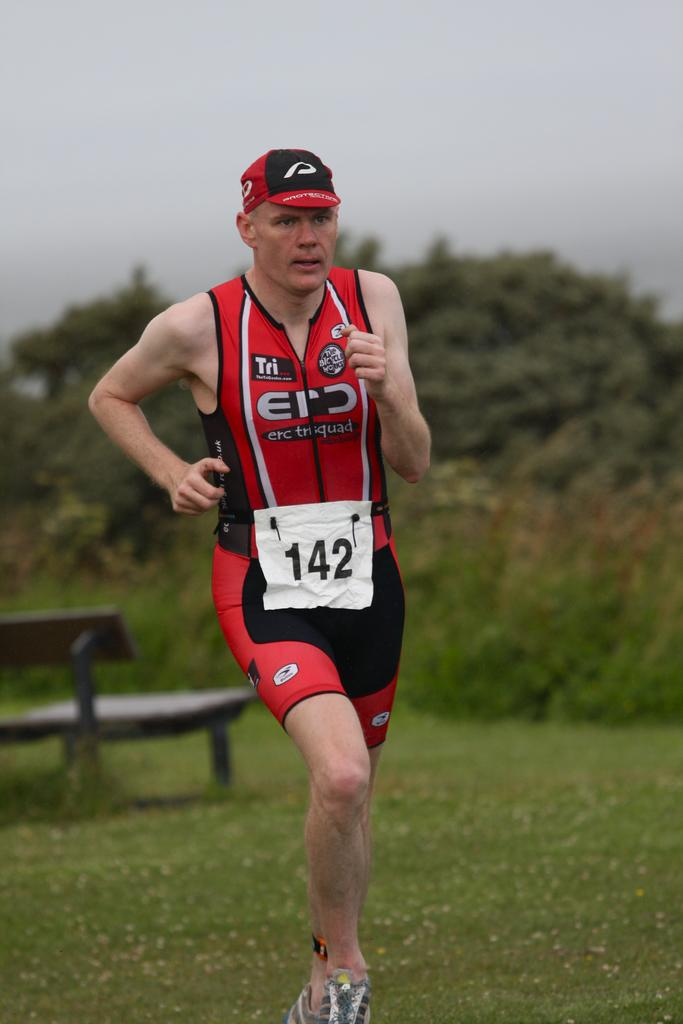<image>
Relay a brief, clear account of the picture shown. A runner wearing number 142 runs across a grassy area. 